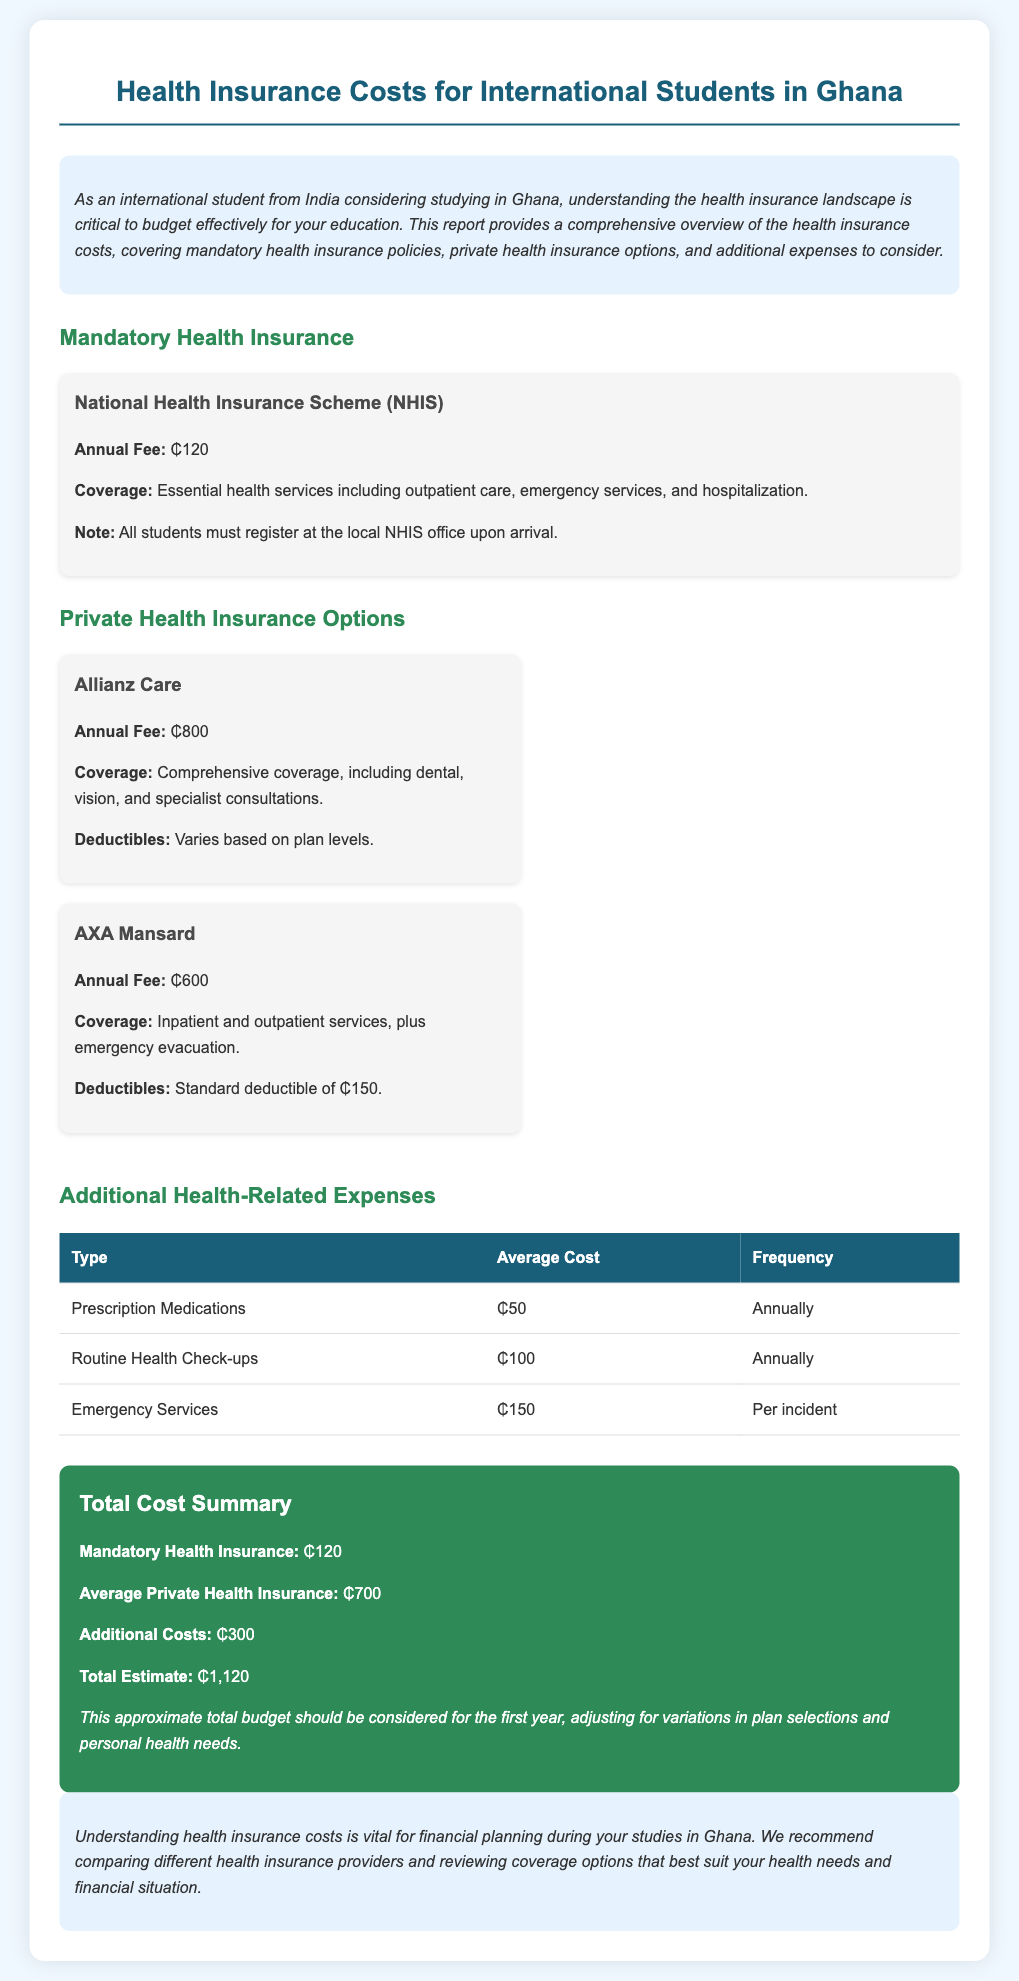What is the annual fee for the National Health Insurance Scheme? The annual fee for the National Health Insurance Scheme is specified in the document.
Answer: ₵120 What is the total estimate for health insurance costs? The total estimate is calculated by adding mandatory health insurance, average private health insurance, and additional costs.
Answer: ₵1,120 How much does Allianz Care charge for health insurance? Allianz Care's annual fee is noted in the breakdown of private health insurance options.
Answer: ₵800 What is the average cost of prescription medications? The document lists the average cost of prescription medications in the additional health-related expenses section.
Answer: ₵50 What type of services does AXA Mansard provide coverage for? AXA Mansard's coverage area is mentioned, indicating they cover specific health services.
Answer: Inpatient and outpatient services, plus emergency evacuation What is included in the coverage of the NHIS? The essential health services provided by the NHIS are outlined in the document.
Answer: Essential health services including outpatient care, emergency services, and hospitalization What is the standard deductible for AXA Mansard? The document specifies the standard deductible related to the AXA Mansard health insurance plan.
Answer: ₵150 How often should routine health check-ups be conducted according to the document? The frequency of routine health check-ups is provided in the additional health-related expenses table.
Answer: Annually 